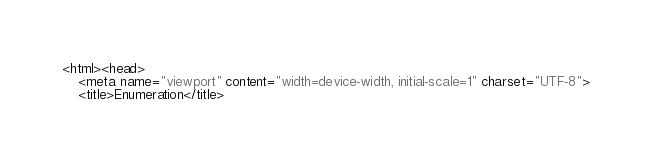Convert code to text. <code><loc_0><loc_0><loc_500><loc_500><_HTML_><html><head>
    <meta name="viewport" content="width=device-width, initial-scale=1" charset="UTF-8">
    <title>Enumeration</title></code> 